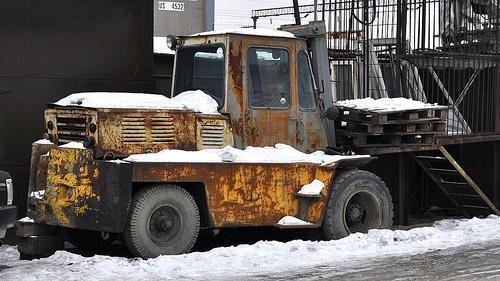How many elephants are pictured?
Give a very brief answer. 0. 